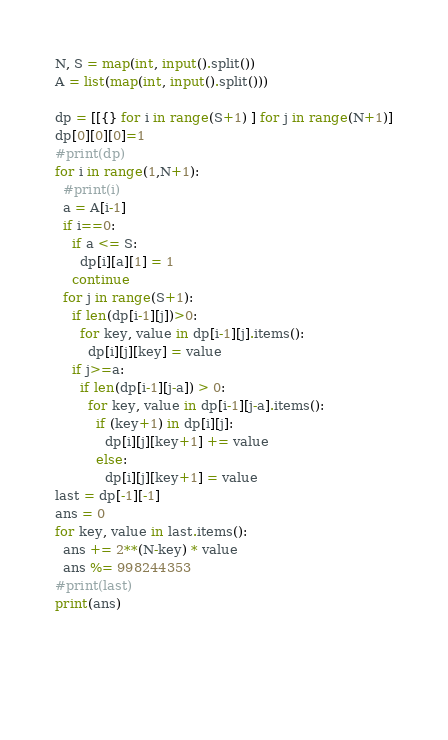<code> <loc_0><loc_0><loc_500><loc_500><_Python_>N, S = map(int, input().split())
A = list(map(int, input().split()))

dp = [[{} for i in range(S+1) ] for j in range(N+1)]
dp[0][0][0]=1
#print(dp)
for i in range(1,N+1):
  #print(i)
  a = A[i-1]
  if i==0:
    if a <= S:
      dp[i][a][1] = 1  
    continue
  for j in range(S+1):
    if len(dp[i-1][j])>0:
      for key, value in dp[i-1][j].items():
        dp[i][j][key] = value
    if j>=a:
      if len(dp[i-1][j-a]) > 0:
        for key, value in dp[i-1][j-a].items():
          if (key+1) in dp[i][j]:
            dp[i][j][key+1] += value
          else:
            dp[i][j][key+1] = value
last = dp[-1][-1]
ans = 0
for key, value in last.items():
  ans += 2**(N-key) * value
  ans %= 998244353
#print(last)
print(ans)
    
    
      
      </code> 